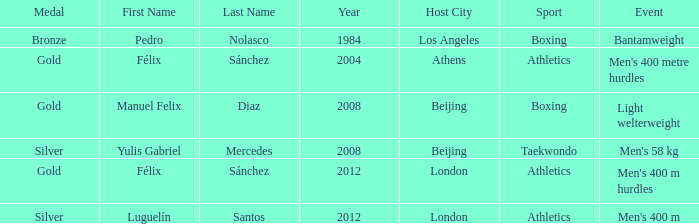Which Games had a Name of manuel felix diaz? 2008 Beijing. 